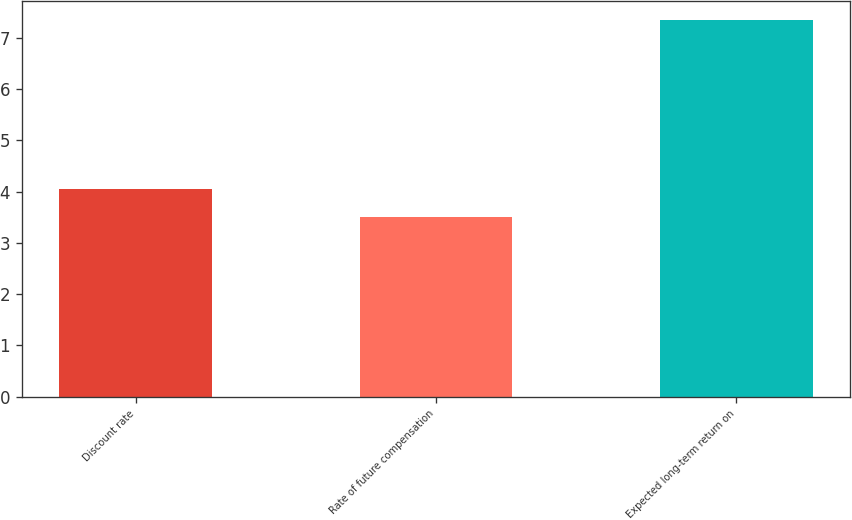Convert chart. <chart><loc_0><loc_0><loc_500><loc_500><bar_chart><fcel>Discount rate<fcel>Rate of future compensation<fcel>Expected long-term return on<nl><fcel>4.04<fcel>3.5<fcel>7.35<nl></chart> 